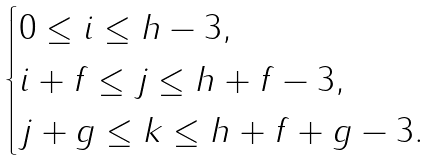Convert formula to latex. <formula><loc_0><loc_0><loc_500><loc_500>\begin{cases} 0 \leq i \leq h - 3 , \\ i + f \leq j \leq h + f - 3 , \\ j + g \leq k \leq h + f + g - 3 . \end{cases}</formula> 